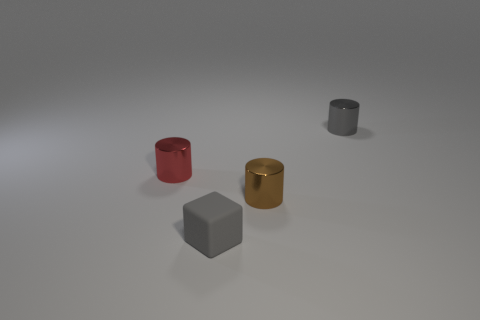Add 4 tiny metallic blocks. How many objects exist? 8 Subtract all cylinders. How many objects are left? 1 Add 3 gray things. How many gray things are left? 5 Add 1 tiny gray rubber things. How many tiny gray rubber things exist? 2 Subtract 0 purple spheres. How many objects are left? 4 Subtract all gray shiny spheres. Subtract all small red cylinders. How many objects are left? 3 